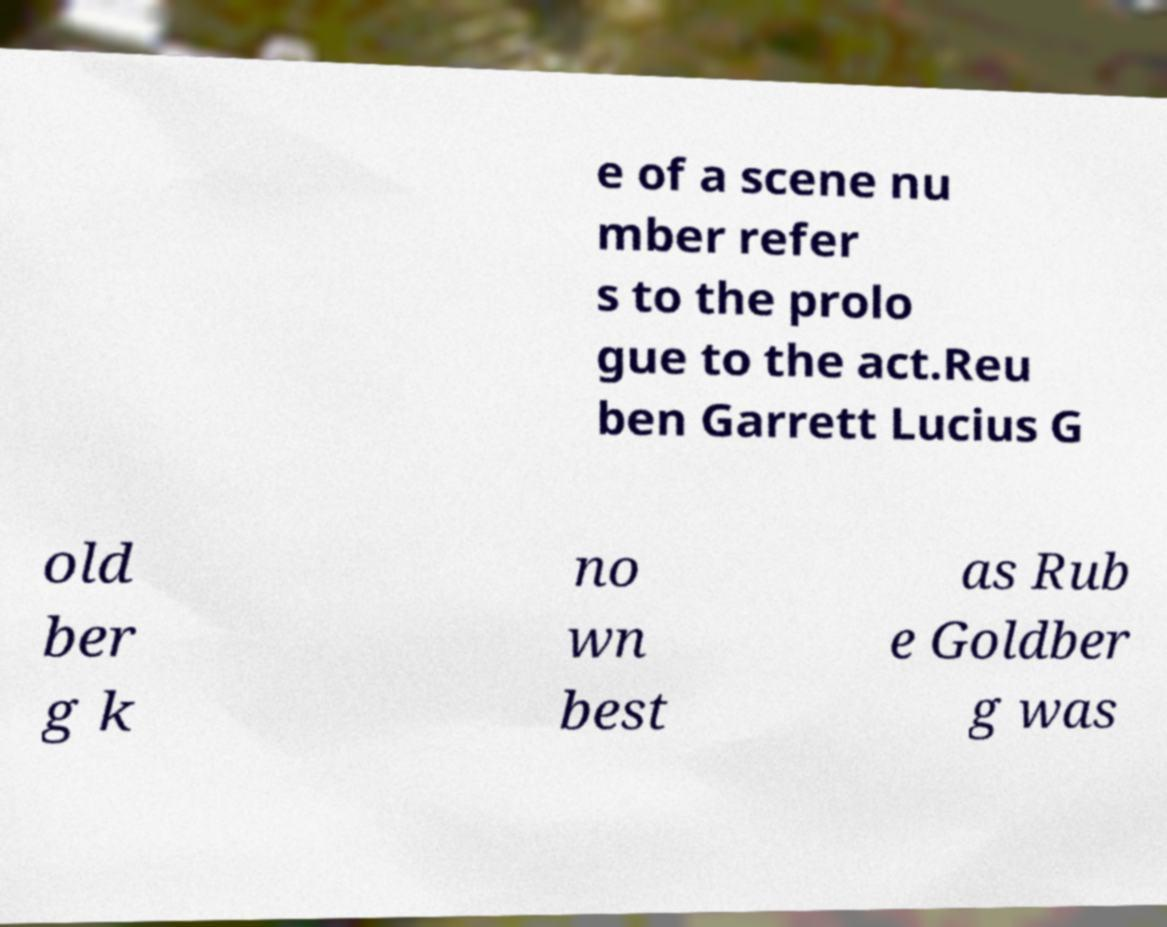Please identify and transcribe the text found in this image. e of a scene nu mber refer s to the prolo gue to the act.Reu ben Garrett Lucius G old ber g k no wn best as Rub e Goldber g was 